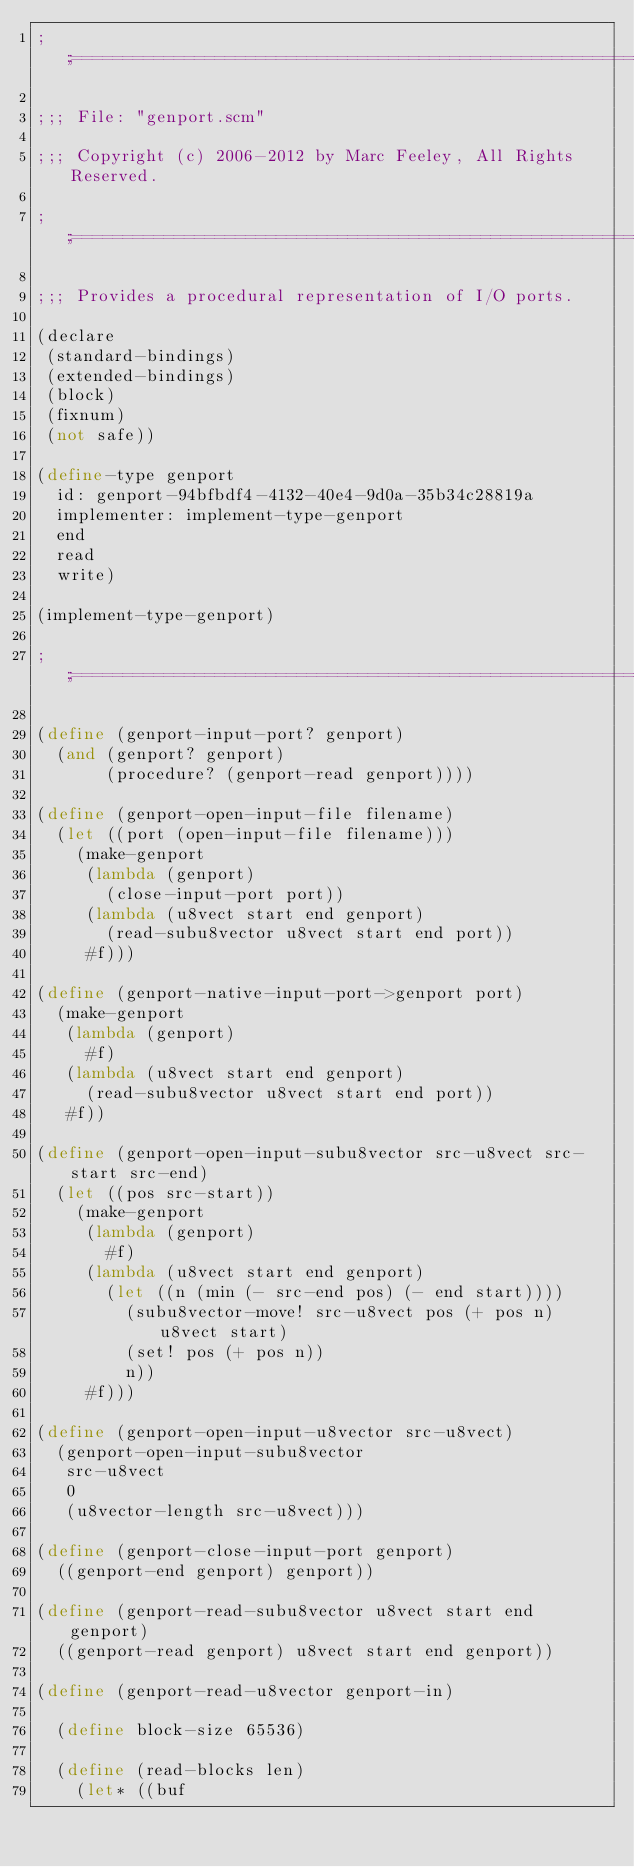<code> <loc_0><loc_0><loc_500><loc_500><_Scheme_>;;;============================================================================

;;; File: "genport.scm"

;;; Copyright (c) 2006-2012 by Marc Feeley, All Rights Reserved.

;;;============================================================================

;;; Provides a procedural representation of I/O ports.

(declare
 (standard-bindings)
 (extended-bindings)
 (block)
 (fixnum)
 (not safe))

(define-type genport
  id: genport-94bfbdf4-4132-40e4-9d0a-35b34c28819a
  implementer: implement-type-genport
  end
  read
  write)

(implement-type-genport)

;;;============================================================================

(define (genport-input-port? genport)
  (and (genport? genport)
       (procedure? (genport-read genport))))

(define (genport-open-input-file filename)
  (let ((port (open-input-file filename)))
    (make-genport
     (lambda (genport)
       (close-input-port port))
     (lambda (u8vect start end genport)
       (read-subu8vector u8vect start end port))
     #f)))

(define (genport-native-input-port->genport port)
  (make-genport
   (lambda (genport)
     #f)
   (lambda (u8vect start end genport)
     (read-subu8vector u8vect start end port))
   #f))

(define (genport-open-input-subu8vector src-u8vect src-start src-end)
  (let ((pos src-start))
    (make-genport
     (lambda (genport)
       #f)
     (lambda (u8vect start end genport)
       (let ((n (min (- src-end pos) (- end start))))
         (subu8vector-move! src-u8vect pos (+ pos n) u8vect start)
         (set! pos (+ pos n))
         n))
     #f)))

(define (genport-open-input-u8vector src-u8vect)
  (genport-open-input-subu8vector
   src-u8vect
   0
   (u8vector-length src-u8vect)))

(define (genport-close-input-port genport)
  ((genport-end genport) genport))

(define (genport-read-subu8vector u8vect start end genport)
  ((genport-read genport) u8vect start end genport))

(define (genport-read-u8vector genport-in)

  (define block-size 65536)

  (define (read-blocks len)
    (let* ((buf</code> 